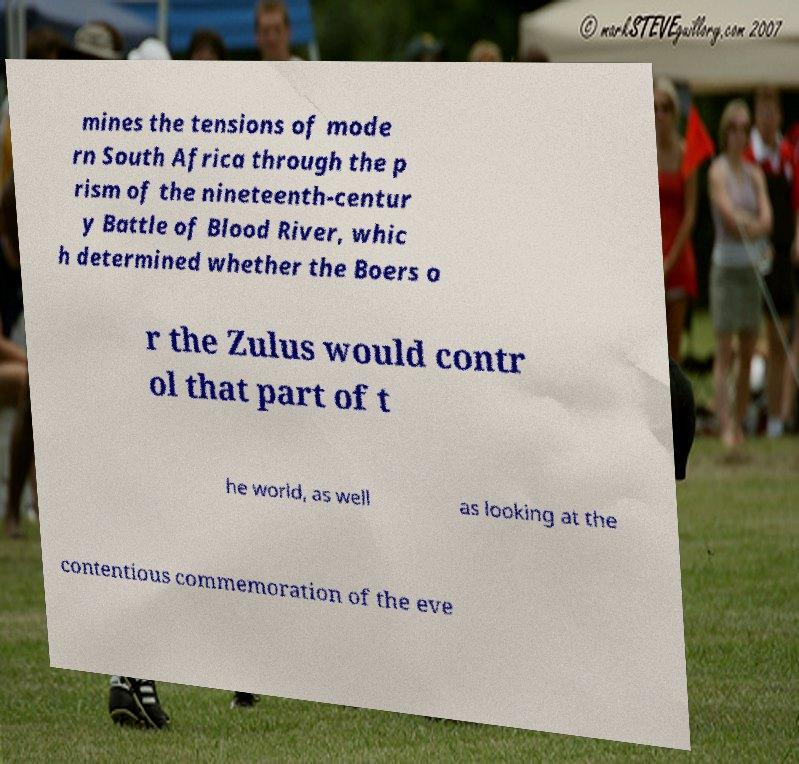Could you assist in decoding the text presented in this image and type it out clearly? mines the tensions of mode rn South Africa through the p rism of the nineteenth-centur y Battle of Blood River, whic h determined whether the Boers o r the Zulus would contr ol that part of t he world, as well as looking at the contentious commemoration of the eve 